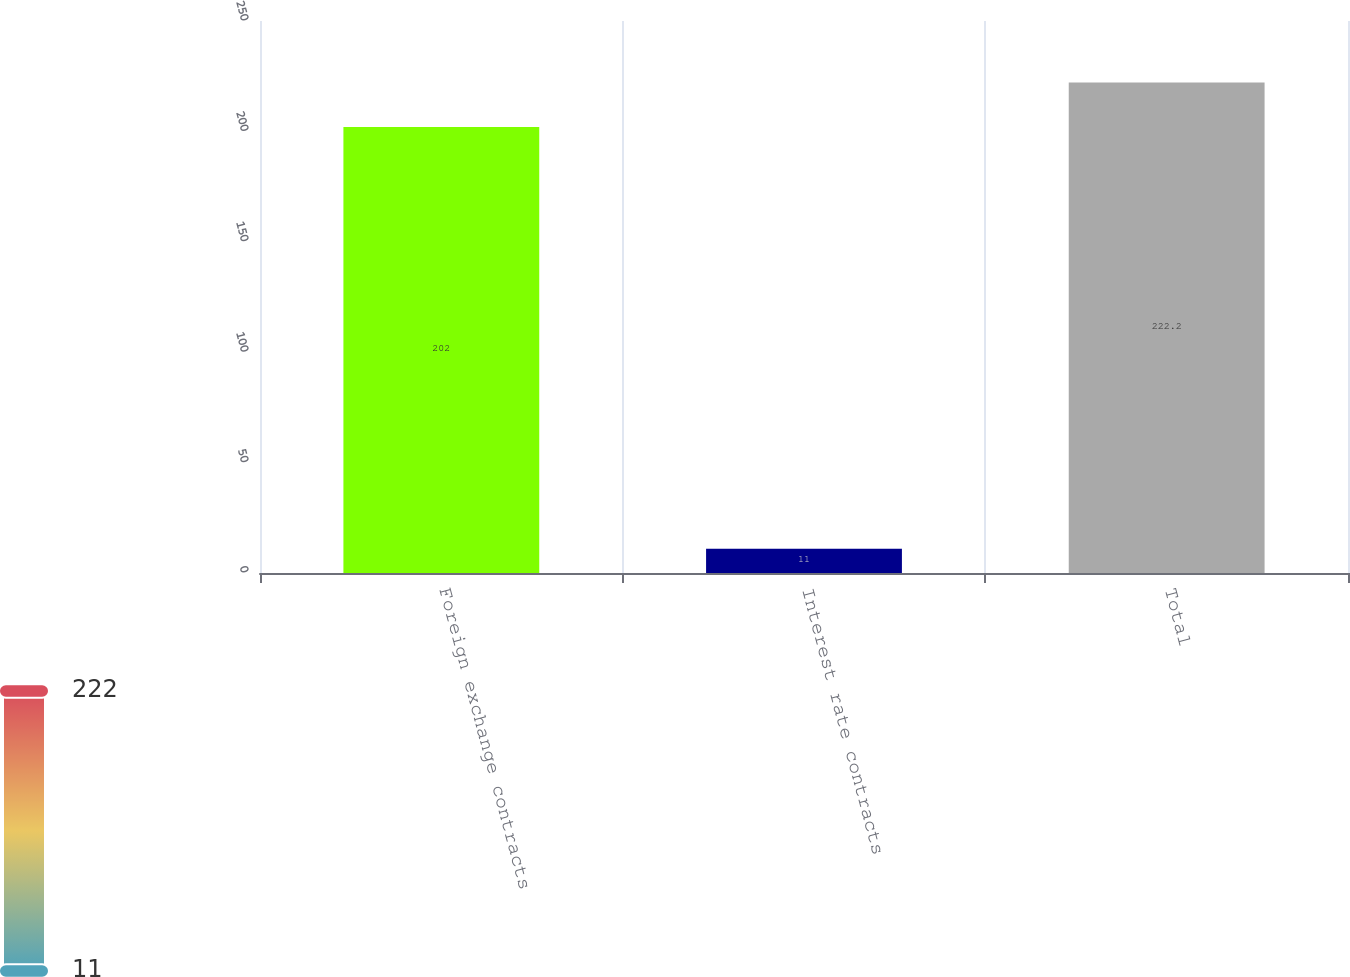Convert chart. <chart><loc_0><loc_0><loc_500><loc_500><bar_chart><fcel>Foreign exchange contracts<fcel>Interest rate contracts<fcel>Total<nl><fcel>202<fcel>11<fcel>222.2<nl></chart> 